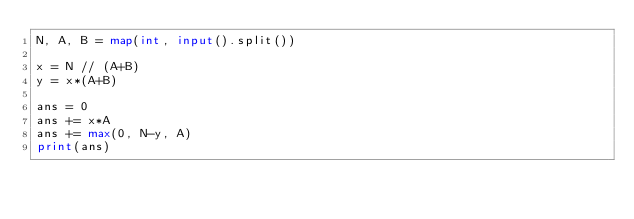Convert code to text. <code><loc_0><loc_0><loc_500><loc_500><_Python_>N, A, B = map(int, input().split())

x = N // (A+B)
y = x*(A+B)

ans = 0
ans += x*A
ans += max(0, N-y, A)
print(ans)</code> 